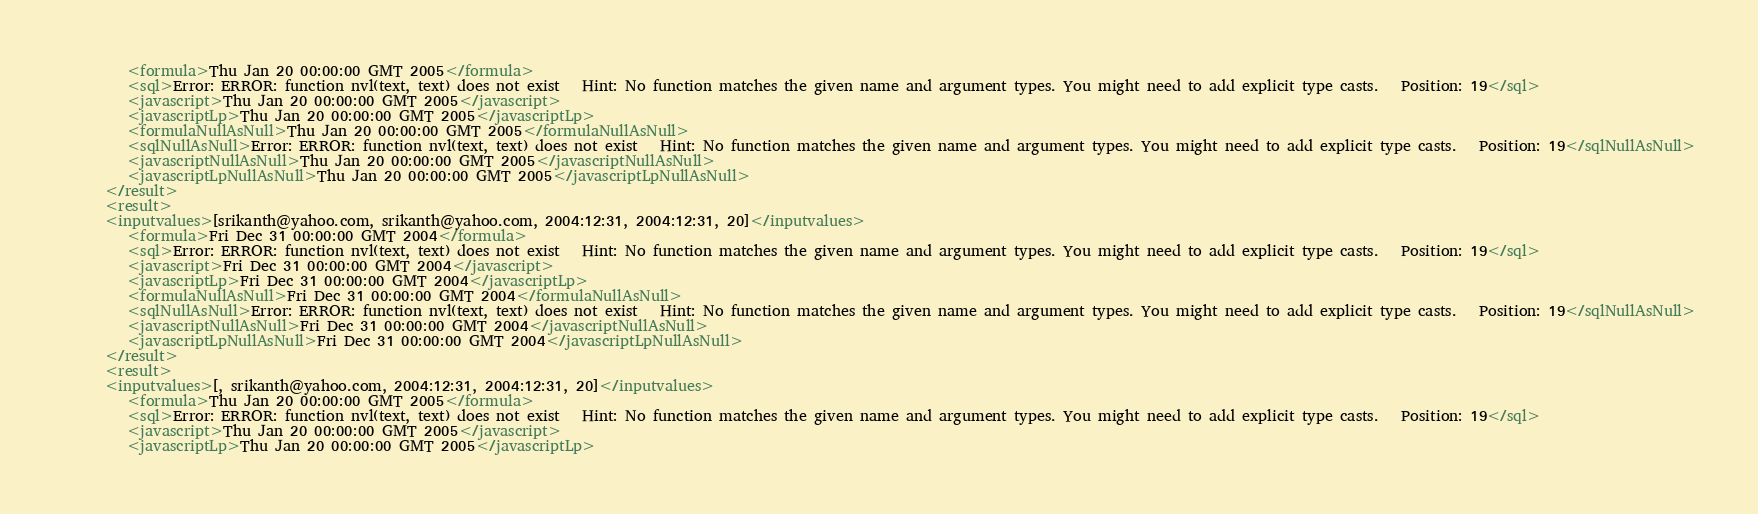<code> <loc_0><loc_0><loc_500><loc_500><_XML_>         <formula>Thu Jan 20 00:00:00 GMT 2005</formula>
         <sql>Error: ERROR: function nvl(text, text) does not exist   Hint: No function matches the given name and argument types. You might need to add explicit type casts.   Position: 19</sql>
         <javascript>Thu Jan 20 00:00:00 GMT 2005</javascript>
         <javascriptLp>Thu Jan 20 00:00:00 GMT 2005</javascriptLp>
         <formulaNullAsNull>Thu Jan 20 00:00:00 GMT 2005</formulaNullAsNull>
         <sqlNullAsNull>Error: ERROR: function nvl(text, text) does not exist   Hint: No function matches the given name and argument types. You might need to add explicit type casts.   Position: 19</sqlNullAsNull>
         <javascriptNullAsNull>Thu Jan 20 00:00:00 GMT 2005</javascriptNullAsNull>
         <javascriptLpNullAsNull>Thu Jan 20 00:00:00 GMT 2005</javascriptLpNullAsNull>
      </result>
      <result>
      <inputvalues>[srikanth@yahoo.com, srikanth@yahoo.com, 2004:12:31, 2004:12:31, 20]</inputvalues>
         <formula>Fri Dec 31 00:00:00 GMT 2004</formula>
         <sql>Error: ERROR: function nvl(text, text) does not exist   Hint: No function matches the given name and argument types. You might need to add explicit type casts.   Position: 19</sql>
         <javascript>Fri Dec 31 00:00:00 GMT 2004</javascript>
         <javascriptLp>Fri Dec 31 00:00:00 GMT 2004</javascriptLp>
         <formulaNullAsNull>Fri Dec 31 00:00:00 GMT 2004</formulaNullAsNull>
         <sqlNullAsNull>Error: ERROR: function nvl(text, text) does not exist   Hint: No function matches the given name and argument types. You might need to add explicit type casts.   Position: 19</sqlNullAsNull>
         <javascriptNullAsNull>Fri Dec 31 00:00:00 GMT 2004</javascriptNullAsNull>
         <javascriptLpNullAsNull>Fri Dec 31 00:00:00 GMT 2004</javascriptLpNullAsNull>
      </result>
      <result>
      <inputvalues>[, srikanth@yahoo.com, 2004:12:31, 2004:12:31, 20]</inputvalues>
         <formula>Thu Jan 20 00:00:00 GMT 2005</formula>
         <sql>Error: ERROR: function nvl(text, text) does not exist   Hint: No function matches the given name and argument types. You might need to add explicit type casts.   Position: 19</sql>
         <javascript>Thu Jan 20 00:00:00 GMT 2005</javascript>
         <javascriptLp>Thu Jan 20 00:00:00 GMT 2005</javascriptLp></code> 